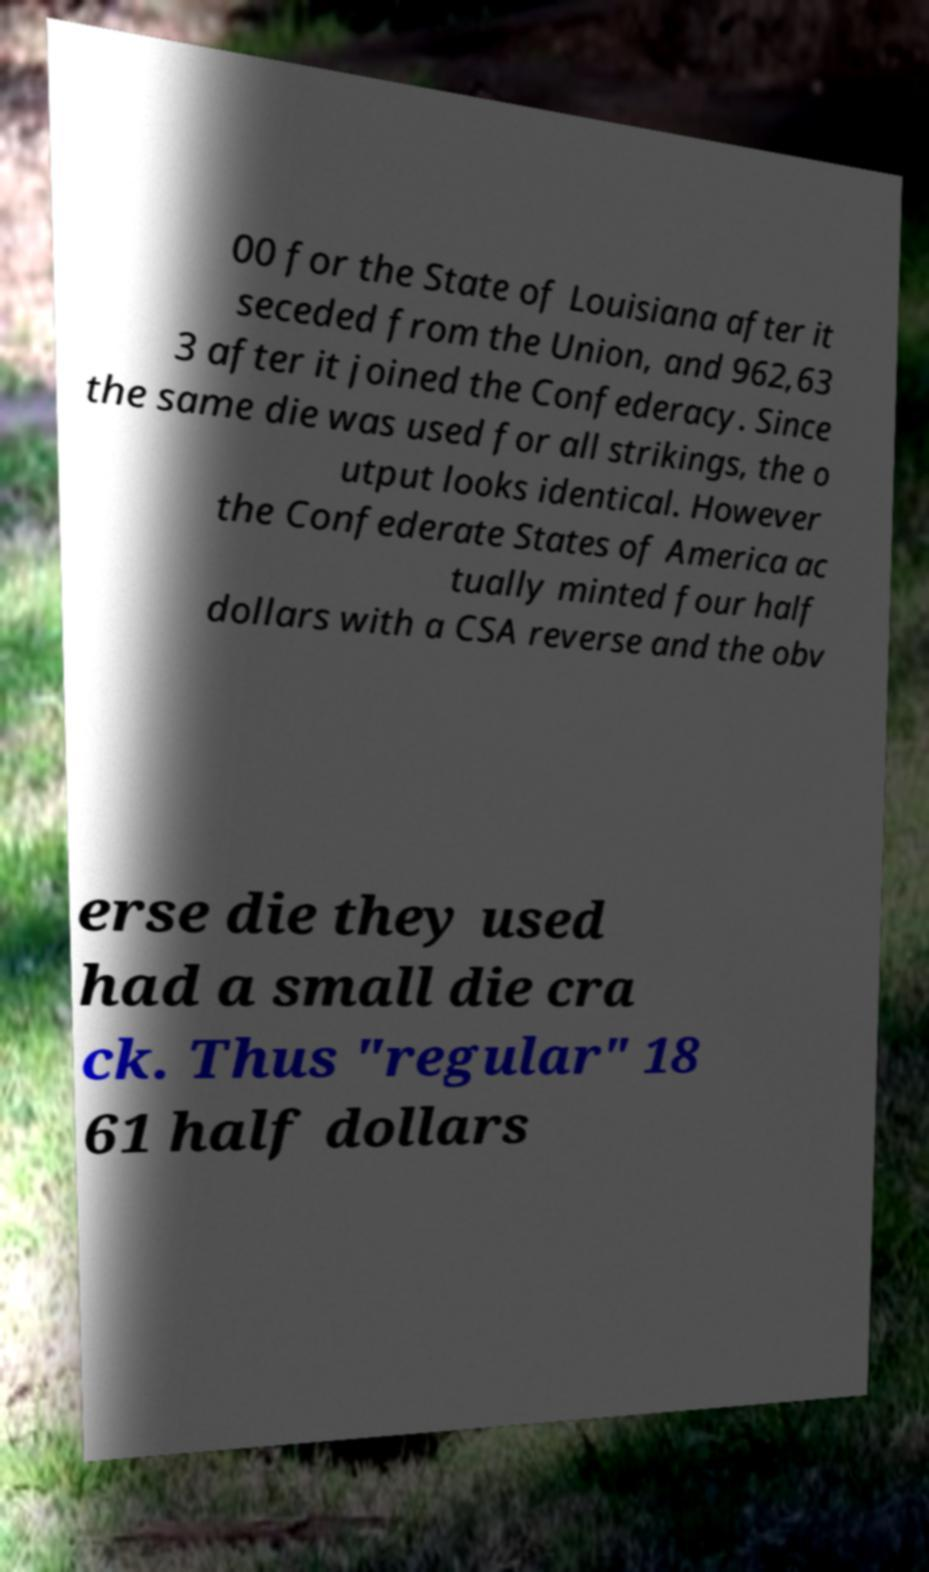For documentation purposes, I need the text within this image transcribed. Could you provide that? 00 for the State of Louisiana after it seceded from the Union, and 962,63 3 after it joined the Confederacy. Since the same die was used for all strikings, the o utput looks identical. However the Confederate States of America ac tually minted four half dollars with a CSA reverse and the obv erse die they used had a small die cra ck. Thus "regular" 18 61 half dollars 